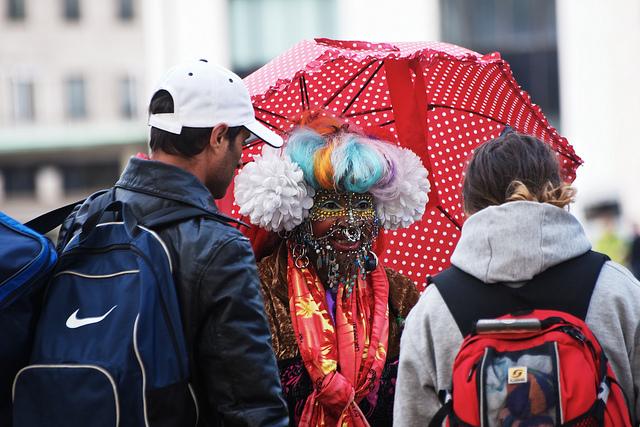Is the scarf wrapped around the man's neck?
Short answer required. Yes. What color is grandma's mustache?
Answer briefly. Brown. What color is the man's coat?
Concise answer only. Black. Are any of these people in costume?
Keep it brief. Yes. Is the umbrella very masculine?
Answer briefly. No. 